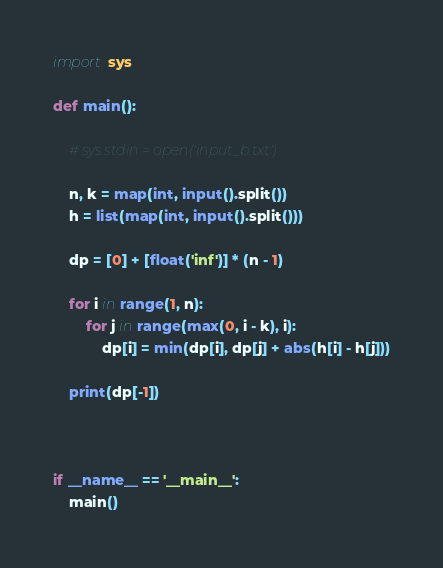<code> <loc_0><loc_0><loc_500><loc_500><_Python_>import sys

def main():
    
    # sys.stdin = open('input_b.txt')

    n, k = map(int, input().split())
    h = list(map(int, input().split()))

    dp = [0] + [float('inf')] * (n - 1)
    
    for i in range(1, n):
        for j in range(max(0, i - k), i):
            dp[i] = min(dp[i], dp[j] + abs(h[i] - h[j]))

    print(dp[-1])



if __name__ == '__main__':
    main()
</code> 